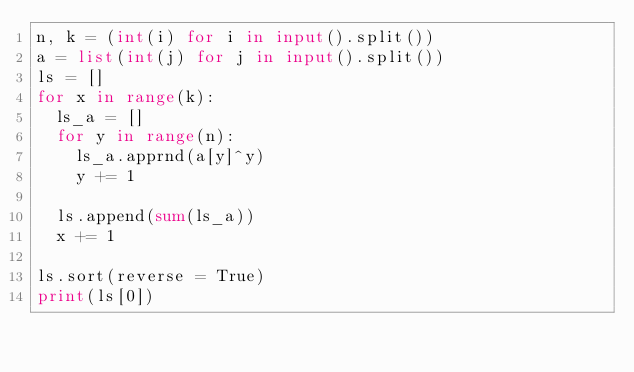Convert code to text. <code><loc_0><loc_0><loc_500><loc_500><_Python_>n, k = (int(i) for i in input().split())
a = list(int(j) for j in input().split())
ls = []
for x in range(k):
  ls_a = []
  for y in range(n):
    ls_a.apprnd(a[y]^y)
    y += 1
    
  ls.append(sum(ls_a))
  x += 1

ls.sort(reverse = True)
print(ls[0])
  </code> 